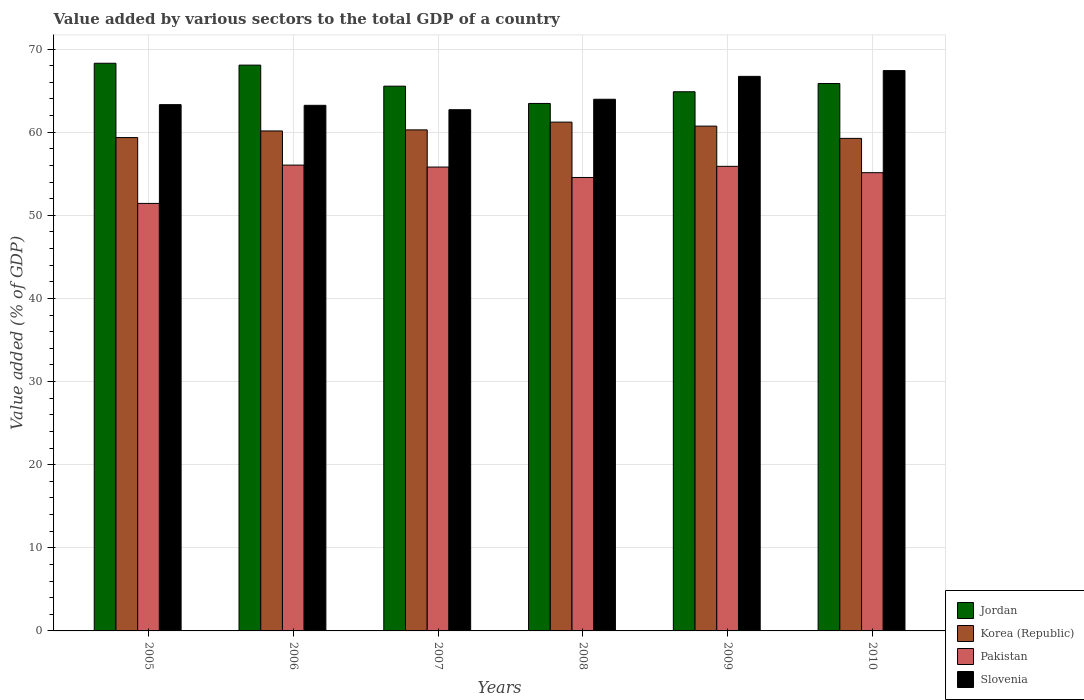How many bars are there on the 5th tick from the left?
Your answer should be very brief. 4. How many bars are there on the 6th tick from the right?
Offer a terse response. 4. What is the label of the 3rd group of bars from the left?
Your answer should be compact. 2007. What is the value added by various sectors to the total GDP in Pakistan in 2006?
Keep it short and to the point. 56.04. Across all years, what is the maximum value added by various sectors to the total GDP in Jordan?
Your response must be concise. 68.3. Across all years, what is the minimum value added by various sectors to the total GDP in Jordan?
Make the answer very short. 63.46. In which year was the value added by various sectors to the total GDP in Slovenia maximum?
Ensure brevity in your answer.  2010. What is the total value added by various sectors to the total GDP in Jordan in the graph?
Ensure brevity in your answer.  396.1. What is the difference between the value added by various sectors to the total GDP in Slovenia in 2005 and that in 2009?
Offer a very short reply. -3.4. What is the difference between the value added by various sectors to the total GDP in Korea (Republic) in 2010 and the value added by various sectors to the total GDP in Pakistan in 2005?
Provide a succinct answer. 7.83. What is the average value added by various sectors to the total GDP in Slovenia per year?
Provide a succinct answer. 64.56. In the year 2010, what is the difference between the value added by various sectors to the total GDP in Korea (Republic) and value added by various sectors to the total GDP in Slovenia?
Ensure brevity in your answer.  -8.15. In how many years, is the value added by various sectors to the total GDP in Slovenia greater than 38 %?
Your answer should be compact. 6. What is the ratio of the value added by various sectors to the total GDP in Pakistan in 2005 to that in 2010?
Your answer should be very brief. 0.93. Is the difference between the value added by various sectors to the total GDP in Korea (Republic) in 2007 and 2009 greater than the difference between the value added by various sectors to the total GDP in Slovenia in 2007 and 2009?
Give a very brief answer. Yes. What is the difference between the highest and the second highest value added by various sectors to the total GDP in Jordan?
Your response must be concise. 0.22. What is the difference between the highest and the lowest value added by various sectors to the total GDP in Pakistan?
Provide a short and direct response. 4.61. In how many years, is the value added by various sectors to the total GDP in Pakistan greater than the average value added by various sectors to the total GDP in Pakistan taken over all years?
Your response must be concise. 4. Is the sum of the value added by various sectors to the total GDP in Pakistan in 2005 and 2009 greater than the maximum value added by various sectors to the total GDP in Jordan across all years?
Your response must be concise. Yes. Is it the case that in every year, the sum of the value added by various sectors to the total GDP in Slovenia and value added by various sectors to the total GDP in Korea (Republic) is greater than the sum of value added by various sectors to the total GDP in Pakistan and value added by various sectors to the total GDP in Jordan?
Offer a very short reply. No. What does the 1st bar from the right in 2007 represents?
Offer a terse response. Slovenia. Is it the case that in every year, the sum of the value added by various sectors to the total GDP in Slovenia and value added by various sectors to the total GDP in Pakistan is greater than the value added by various sectors to the total GDP in Jordan?
Provide a short and direct response. Yes. Are the values on the major ticks of Y-axis written in scientific E-notation?
Offer a very short reply. No. Where does the legend appear in the graph?
Give a very brief answer. Bottom right. How are the legend labels stacked?
Your answer should be compact. Vertical. What is the title of the graph?
Your answer should be compact. Value added by various sectors to the total GDP of a country. Does "Paraguay" appear as one of the legend labels in the graph?
Provide a succinct answer. No. What is the label or title of the Y-axis?
Offer a very short reply. Value added (% of GDP). What is the Value added (% of GDP) in Jordan in 2005?
Your answer should be very brief. 68.3. What is the Value added (% of GDP) in Korea (Republic) in 2005?
Ensure brevity in your answer.  59.36. What is the Value added (% of GDP) in Pakistan in 2005?
Give a very brief answer. 51.43. What is the Value added (% of GDP) of Slovenia in 2005?
Make the answer very short. 63.32. What is the Value added (% of GDP) in Jordan in 2006?
Give a very brief answer. 68.07. What is the Value added (% of GDP) in Korea (Republic) in 2006?
Your answer should be very brief. 60.15. What is the Value added (% of GDP) of Pakistan in 2006?
Offer a very short reply. 56.04. What is the Value added (% of GDP) of Slovenia in 2006?
Offer a terse response. 63.24. What is the Value added (% of GDP) of Jordan in 2007?
Offer a very short reply. 65.54. What is the Value added (% of GDP) of Korea (Republic) in 2007?
Keep it short and to the point. 60.28. What is the Value added (% of GDP) of Pakistan in 2007?
Your answer should be very brief. 55.81. What is the Value added (% of GDP) of Slovenia in 2007?
Provide a short and direct response. 62.71. What is the Value added (% of GDP) of Jordan in 2008?
Offer a terse response. 63.46. What is the Value added (% of GDP) in Korea (Republic) in 2008?
Ensure brevity in your answer.  61.21. What is the Value added (% of GDP) of Pakistan in 2008?
Give a very brief answer. 54.56. What is the Value added (% of GDP) of Slovenia in 2008?
Your response must be concise. 63.96. What is the Value added (% of GDP) in Jordan in 2009?
Make the answer very short. 64.87. What is the Value added (% of GDP) in Korea (Republic) in 2009?
Provide a succinct answer. 60.73. What is the Value added (% of GDP) in Pakistan in 2009?
Make the answer very short. 55.89. What is the Value added (% of GDP) in Slovenia in 2009?
Ensure brevity in your answer.  66.72. What is the Value added (% of GDP) of Jordan in 2010?
Your response must be concise. 65.86. What is the Value added (% of GDP) in Korea (Republic) in 2010?
Offer a very short reply. 59.26. What is the Value added (% of GDP) of Pakistan in 2010?
Offer a very short reply. 55.13. What is the Value added (% of GDP) in Slovenia in 2010?
Give a very brief answer. 67.41. Across all years, what is the maximum Value added (% of GDP) in Jordan?
Your answer should be very brief. 68.3. Across all years, what is the maximum Value added (% of GDP) of Korea (Republic)?
Give a very brief answer. 61.21. Across all years, what is the maximum Value added (% of GDP) of Pakistan?
Ensure brevity in your answer.  56.04. Across all years, what is the maximum Value added (% of GDP) in Slovenia?
Make the answer very short. 67.41. Across all years, what is the minimum Value added (% of GDP) of Jordan?
Give a very brief answer. 63.46. Across all years, what is the minimum Value added (% of GDP) of Korea (Republic)?
Offer a terse response. 59.26. Across all years, what is the minimum Value added (% of GDP) in Pakistan?
Keep it short and to the point. 51.43. Across all years, what is the minimum Value added (% of GDP) in Slovenia?
Your answer should be compact. 62.71. What is the total Value added (% of GDP) in Jordan in the graph?
Your answer should be compact. 396.1. What is the total Value added (% of GDP) of Korea (Republic) in the graph?
Offer a very short reply. 361. What is the total Value added (% of GDP) of Pakistan in the graph?
Provide a short and direct response. 328.87. What is the total Value added (% of GDP) of Slovenia in the graph?
Offer a very short reply. 387.36. What is the difference between the Value added (% of GDP) in Jordan in 2005 and that in 2006?
Make the answer very short. 0.22. What is the difference between the Value added (% of GDP) in Korea (Republic) in 2005 and that in 2006?
Keep it short and to the point. -0.8. What is the difference between the Value added (% of GDP) of Pakistan in 2005 and that in 2006?
Offer a very short reply. -4.61. What is the difference between the Value added (% of GDP) in Slovenia in 2005 and that in 2006?
Your answer should be very brief. 0.08. What is the difference between the Value added (% of GDP) in Jordan in 2005 and that in 2007?
Your answer should be compact. 2.76. What is the difference between the Value added (% of GDP) in Korea (Republic) in 2005 and that in 2007?
Offer a terse response. -0.93. What is the difference between the Value added (% of GDP) in Pakistan in 2005 and that in 2007?
Ensure brevity in your answer.  -4.37. What is the difference between the Value added (% of GDP) in Slovenia in 2005 and that in 2007?
Make the answer very short. 0.61. What is the difference between the Value added (% of GDP) of Jordan in 2005 and that in 2008?
Ensure brevity in your answer.  4.83. What is the difference between the Value added (% of GDP) of Korea (Republic) in 2005 and that in 2008?
Your answer should be very brief. -1.86. What is the difference between the Value added (% of GDP) of Pakistan in 2005 and that in 2008?
Keep it short and to the point. -3.12. What is the difference between the Value added (% of GDP) of Slovenia in 2005 and that in 2008?
Offer a very short reply. -0.65. What is the difference between the Value added (% of GDP) in Jordan in 2005 and that in 2009?
Give a very brief answer. 3.43. What is the difference between the Value added (% of GDP) in Korea (Republic) in 2005 and that in 2009?
Ensure brevity in your answer.  -1.38. What is the difference between the Value added (% of GDP) of Pakistan in 2005 and that in 2009?
Your answer should be very brief. -4.46. What is the difference between the Value added (% of GDP) in Slovenia in 2005 and that in 2009?
Your answer should be very brief. -3.4. What is the difference between the Value added (% of GDP) in Jordan in 2005 and that in 2010?
Make the answer very short. 2.44. What is the difference between the Value added (% of GDP) of Korea (Republic) in 2005 and that in 2010?
Provide a succinct answer. 0.1. What is the difference between the Value added (% of GDP) of Pakistan in 2005 and that in 2010?
Your answer should be very brief. -3.7. What is the difference between the Value added (% of GDP) of Slovenia in 2005 and that in 2010?
Provide a succinct answer. -4.09. What is the difference between the Value added (% of GDP) of Jordan in 2006 and that in 2007?
Your response must be concise. 2.53. What is the difference between the Value added (% of GDP) in Korea (Republic) in 2006 and that in 2007?
Keep it short and to the point. -0.13. What is the difference between the Value added (% of GDP) in Pakistan in 2006 and that in 2007?
Offer a very short reply. 0.24. What is the difference between the Value added (% of GDP) of Slovenia in 2006 and that in 2007?
Your answer should be compact. 0.53. What is the difference between the Value added (% of GDP) in Jordan in 2006 and that in 2008?
Offer a very short reply. 4.61. What is the difference between the Value added (% of GDP) in Korea (Republic) in 2006 and that in 2008?
Give a very brief answer. -1.06. What is the difference between the Value added (% of GDP) of Pakistan in 2006 and that in 2008?
Offer a terse response. 1.49. What is the difference between the Value added (% of GDP) in Slovenia in 2006 and that in 2008?
Ensure brevity in your answer.  -0.73. What is the difference between the Value added (% of GDP) in Jordan in 2006 and that in 2009?
Your answer should be very brief. 3.21. What is the difference between the Value added (% of GDP) in Korea (Republic) in 2006 and that in 2009?
Ensure brevity in your answer.  -0.58. What is the difference between the Value added (% of GDP) in Pakistan in 2006 and that in 2009?
Offer a very short reply. 0.15. What is the difference between the Value added (% of GDP) in Slovenia in 2006 and that in 2009?
Make the answer very short. -3.48. What is the difference between the Value added (% of GDP) in Jordan in 2006 and that in 2010?
Your answer should be very brief. 2.21. What is the difference between the Value added (% of GDP) in Korea (Republic) in 2006 and that in 2010?
Your response must be concise. 0.89. What is the difference between the Value added (% of GDP) in Pakistan in 2006 and that in 2010?
Your answer should be compact. 0.91. What is the difference between the Value added (% of GDP) of Slovenia in 2006 and that in 2010?
Your answer should be compact. -4.18. What is the difference between the Value added (% of GDP) of Jordan in 2007 and that in 2008?
Make the answer very short. 2.08. What is the difference between the Value added (% of GDP) of Korea (Republic) in 2007 and that in 2008?
Offer a terse response. -0.93. What is the difference between the Value added (% of GDP) in Pakistan in 2007 and that in 2008?
Your response must be concise. 1.25. What is the difference between the Value added (% of GDP) of Slovenia in 2007 and that in 2008?
Offer a very short reply. -1.26. What is the difference between the Value added (% of GDP) in Jordan in 2007 and that in 2009?
Offer a very short reply. 0.67. What is the difference between the Value added (% of GDP) in Korea (Republic) in 2007 and that in 2009?
Provide a short and direct response. -0.45. What is the difference between the Value added (% of GDP) in Pakistan in 2007 and that in 2009?
Your answer should be very brief. -0.09. What is the difference between the Value added (% of GDP) in Slovenia in 2007 and that in 2009?
Offer a very short reply. -4.01. What is the difference between the Value added (% of GDP) of Jordan in 2007 and that in 2010?
Provide a short and direct response. -0.32. What is the difference between the Value added (% of GDP) of Korea (Republic) in 2007 and that in 2010?
Give a very brief answer. 1.02. What is the difference between the Value added (% of GDP) of Pakistan in 2007 and that in 2010?
Your response must be concise. 0.68. What is the difference between the Value added (% of GDP) in Slovenia in 2007 and that in 2010?
Ensure brevity in your answer.  -4.7. What is the difference between the Value added (% of GDP) in Jordan in 2008 and that in 2009?
Give a very brief answer. -1.41. What is the difference between the Value added (% of GDP) of Korea (Republic) in 2008 and that in 2009?
Give a very brief answer. 0.48. What is the difference between the Value added (% of GDP) in Pakistan in 2008 and that in 2009?
Offer a very short reply. -1.34. What is the difference between the Value added (% of GDP) in Slovenia in 2008 and that in 2009?
Keep it short and to the point. -2.75. What is the difference between the Value added (% of GDP) in Jordan in 2008 and that in 2010?
Provide a succinct answer. -2.4. What is the difference between the Value added (% of GDP) of Korea (Republic) in 2008 and that in 2010?
Your response must be concise. 1.96. What is the difference between the Value added (% of GDP) of Pakistan in 2008 and that in 2010?
Offer a terse response. -0.58. What is the difference between the Value added (% of GDP) in Slovenia in 2008 and that in 2010?
Keep it short and to the point. -3.45. What is the difference between the Value added (% of GDP) in Jordan in 2009 and that in 2010?
Your answer should be compact. -0.99. What is the difference between the Value added (% of GDP) of Korea (Republic) in 2009 and that in 2010?
Offer a terse response. 1.47. What is the difference between the Value added (% of GDP) of Pakistan in 2009 and that in 2010?
Provide a short and direct response. 0.76. What is the difference between the Value added (% of GDP) of Slovenia in 2009 and that in 2010?
Your response must be concise. -0.69. What is the difference between the Value added (% of GDP) of Jordan in 2005 and the Value added (% of GDP) of Korea (Republic) in 2006?
Give a very brief answer. 8.14. What is the difference between the Value added (% of GDP) in Jordan in 2005 and the Value added (% of GDP) in Pakistan in 2006?
Give a very brief answer. 12.25. What is the difference between the Value added (% of GDP) in Jordan in 2005 and the Value added (% of GDP) in Slovenia in 2006?
Your answer should be very brief. 5.06. What is the difference between the Value added (% of GDP) in Korea (Republic) in 2005 and the Value added (% of GDP) in Pakistan in 2006?
Offer a very short reply. 3.31. What is the difference between the Value added (% of GDP) in Korea (Republic) in 2005 and the Value added (% of GDP) in Slovenia in 2006?
Offer a very short reply. -3.88. What is the difference between the Value added (% of GDP) in Pakistan in 2005 and the Value added (% of GDP) in Slovenia in 2006?
Offer a terse response. -11.8. What is the difference between the Value added (% of GDP) of Jordan in 2005 and the Value added (% of GDP) of Korea (Republic) in 2007?
Keep it short and to the point. 8.02. What is the difference between the Value added (% of GDP) of Jordan in 2005 and the Value added (% of GDP) of Pakistan in 2007?
Your answer should be compact. 12.49. What is the difference between the Value added (% of GDP) of Jordan in 2005 and the Value added (% of GDP) of Slovenia in 2007?
Make the answer very short. 5.59. What is the difference between the Value added (% of GDP) in Korea (Republic) in 2005 and the Value added (% of GDP) in Pakistan in 2007?
Keep it short and to the point. 3.55. What is the difference between the Value added (% of GDP) in Korea (Republic) in 2005 and the Value added (% of GDP) in Slovenia in 2007?
Your answer should be very brief. -3.35. What is the difference between the Value added (% of GDP) of Pakistan in 2005 and the Value added (% of GDP) of Slovenia in 2007?
Your answer should be compact. -11.27. What is the difference between the Value added (% of GDP) in Jordan in 2005 and the Value added (% of GDP) in Korea (Republic) in 2008?
Your answer should be compact. 7.08. What is the difference between the Value added (% of GDP) in Jordan in 2005 and the Value added (% of GDP) in Pakistan in 2008?
Provide a succinct answer. 13.74. What is the difference between the Value added (% of GDP) in Jordan in 2005 and the Value added (% of GDP) in Slovenia in 2008?
Ensure brevity in your answer.  4.33. What is the difference between the Value added (% of GDP) in Korea (Republic) in 2005 and the Value added (% of GDP) in Pakistan in 2008?
Ensure brevity in your answer.  4.8. What is the difference between the Value added (% of GDP) in Korea (Republic) in 2005 and the Value added (% of GDP) in Slovenia in 2008?
Your answer should be compact. -4.61. What is the difference between the Value added (% of GDP) in Pakistan in 2005 and the Value added (% of GDP) in Slovenia in 2008?
Your answer should be compact. -12.53. What is the difference between the Value added (% of GDP) of Jordan in 2005 and the Value added (% of GDP) of Korea (Republic) in 2009?
Provide a short and direct response. 7.56. What is the difference between the Value added (% of GDP) in Jordan in 2005 and the Value added (% of GDP) in Pakistan in 2009?
Ensure brevity in your answer.  12.4. What is the difference between the Value added (% of GDP) of Jordan in 2005 and the Value added (% of GDP) of Slovenia in 2009?
Keep it short and to the point. 1.58. What is the difference between the Value added (% of GDP) of Korea (Republic) in 2005 and the Value added (% of GDP) of Pakistan in 2009?
Your response must be concise. 3.46. What is the difference between the Value added (% of GDP) of Korea (Republic) in 2005 and the Value added (% of GDP) of Slovenia in 2009?
Provide a succinct answer. -7.36. What is the difference between the Value added (% of GDP) of Pakistan in 2005 and the Value added (% of GDP) of Slovenia in 2009?
Offer a terse response. -15.29. What is the difference between the Value added (% of GDP) of Jordan in 2005 and the Value added (% of GDP) of Korea (Republic) in 2010?
Keep it short and to the point. 9.04. What is the difference between the Value added (% of GDP) in Jordan in 2005 and the Value added (% of GDP) in Pakistan in 2010?
Offer a terse response. 13.16. What is the difference between the Value added (% of GDP) of Jordan in 2005 and the Value added (% of GDP) of Slovenia in 2010?
Offer a terse response. 0.88. What is the difference between the Value added (% of GDP) in Korea (Republic) in 2005 and the Value added (% of GDP) in Pakistan in 2010?
Keep it short and to the point. 4.22. What is the difference between the Value added (% of GDP) in Korea (Republic) in 2005 and the Value added (% of GDP) in Slovenia in 2010?
Offer a very short reply. -8.06. What is the difference between the Value added (% of GDP) of Pakistan in 2005 and the Value added (% of GDP) of Slovenia in 2010?
Offer a very short reply. -15.98. What is the difference between the Value added (% of GDP) in Jordan in 2006 and the Value added (% of GDP) in Korea (Republic) in 2007?
Provide a short and direct response. 7.79. What is the difference between the Value added (% of GDP) of Jordan in 2006 and the Value added (% of GDP) of Pakistan in 2007?
Give a very brief answer. 12.27. What is the difference between the Value added (% of GDP) of Jordan in 2006 and the Value added (% of GDP) of Slovenia in 2007?
Provide a short and direct response. 5.37. What is the difference between the Value added (% of GDP) of Korea (Republic) in 2006 and the Value added (% of GDP) of Pakistan in 2007?
Provide a succinct answer. 4.35. What is the difference between the Value added (% of GDP) in Korea (Republic) in 2006 and the Value added (% of GDP) in Slovenia in 2007?
Offer a very short reply. -2.56. What is the difference between the Value added (% of GDP) in Pakistan in 2006 and the Value added (% of GDP) in Slovenia in 2007?
Make the answer very short. -6.66. What is the difference between the Value added (% of GDP) in Jordan in 2006 and the Value added (% of GDP) in Korea (Republic) in 2008?
Your response must be concise. 6.86. What is the difference between the Value added (% of GDP) of Jordan in 2006 and the Value added (% of GDP) of Pakistan in 2008?
Make the answer very short. 13.52. What is the difference between the Value added (% of GDP) in Jordan in 2006 and the Value added (% of GDP) in Slovenia in 2008?
Your response must be concise. 4.11. What is the difference between the Value added (% of GDP) in Korea (Republic) in 2006 and the Value added (% of GDP) in Pakistan in 2008?
Give a very brief answer. 5.6. What is the difference between the Value added (% of GDP) of Korea (Republic) in 2006 and the Value added (% of GDP) of Slovenia in 2008?
Keep it short and to the point. -3.81. What is the difference between the Value added (% of GDP) in Pakistan in 2006 and the Value added (% of GDP) in Slovenia in 2008?
Give a very brief answer. -7.92. What is the difference between the Value added (% of GDP) of Jordan in 2006 and the Value added (% of GDP) of Korea (Republic) in 2009?
Give a very brief answer. 7.34. What is the difference between the Value added (% of GDP) in Jordan in 2006 and the Value added (% of GDP) in Pakistan in 2009?
Ensure brevity in your answer.  12.18. What is the difference between the Value added (% of GDP) of Jordan in 2006 and the Value added (% of GDP) of Slovenia in 2009?
Your answer should be compact. 1.35. What is the difference between the Value added (% of GDP) in Korea (Republic) in 2006 and the Value added (% of GDP) in Pakistan in 2009?
Offer a terse response. 4.26. What is the difference between the Value added (% of GDP) of Korea (Republic) in 2006 and the Value added (% of GDP) of Slovenia in 2009?
Provide a short and direct response. -6.57. What is the difference between the Value added (% of GDP) in Pakistan in 2006 and the Value added (% of GDP) in Slovenia in 2009?
Make the answer very short. -10.67. What is the difference between the Value added (% of GDP) in Jordan in 2006 and the Value added (% of GDP) in Korea (Republic) in 2010?
Offer a terse response. 8.81. What is the difference between the Value added (% of GDP) in Jordan in 2006 and the Value added (% of GDP) in Pakistan in 2010?
Offer a terse response. 12.94. What is the difference between the Value added (% of GDP) of Jordan in 2006 and the Value added (% of GDP) of Slovenia in 2010?
Offer a terse response. 0.66. What is the difference between the Value added (% of GDP) in Korea (Republic) in 2006 and the Value added (% of GDP) in Pakistan in 2010?
Provide a short and direct response. 5.02. What is the difference between the Value added (% of GDP) of Korea (Republic) in 2006 and the Value added (% of GDP) of Slovenia in 2010?
Your answer should be compact. -7.26. What is the difference between the Value added (% of GDP) in Pakistan in 2006 and the Value added (% of GDP) in Slovenia in 2010?
Make the answer very short. -11.37. What is the difference between the Value added (% of GDP) in Jordan in 2007 and the Value added (% of GDP) in Korea (Republic) in 2008?
Keep it short and to the point. 4.33. What is the difference between the Value added (% of GDP) in Jordan in 2007 and the Value added (% of GDP) in Pakistan in 2008?
Your response must be concise. 10.99. What is the difference between the Value added (% of GDP) in Jordan in 2007 and the Value added (% of GDP) in Slovenia in 2008?
Your answer should be very brief. 1.58. What is the difference between the Value added (% of GDP) of Korea (Republic) in 2007 and the Value added (% of GDP) of Pakistan in 2008?
Keep it short and to the point. 5.73. What is the difference between the Value added (% of GDP) in Korea (Republic) in 2007 and the Value added (% of GDP) in Slovenia in 2008?
Your answer should be compact. -3.68. What is the difference between the Value added (% of GDP) of Pakistan in 2007 and the Value added (% of GDP) of Slovenia in 2008?
Give a very brief answer. -8.16. What is the difference between the Value added (% of GDP) in Jordan in 2007 and the Value added (% of GDP) in Korea (Republic) in 2009?
Keep it short and to the point. 4.81. What is the difference between the Value added (% of GDP) of Jordan in 2007 and the Value added (% of GDP) of Pakistan in 2009?
Your response must be concise. 9.65. What is the difference between the Value added (% of GDP) of Jordan in 2007 and the Value added (% of GDP) of Slovenia in 2009?
Offer a very short reply. -1.18. What is the difference between the Value added (% of GDP) of Korea (Republic) in 2007 and the Value added (% of GDP) of Pakistan in 2009?
Offer a very short reply. 4.39. What is the difference between the Value added (% of GDP) of Korea (Republic) in 2007 and the Value added (% of GDP) of Slovenia in 2009?
Offer a very short reply. -6.44. What is the difference between the Value added (% of GDP) of Pakistan in 2007 and the Value added (% of GDP) of Slovenia in 2009?
Keep it short and to the point. -10.91. What is the difference between the Value added (% of GDP) in Jordan in 2007 and the Value added (% of GDP) in Korea (Republic) in 2010?
Provide a succinct answer. 6.28. What is the difference between the Value added (% of GDP) in Jordan in 2007 and the Value added (% of GDP) in Pakistan in 2010?
Your response must be concise. 10.41. What is the difference between the Value added (% of GDP) of Jordan in 2007 and the Value added (% of GDP) of Slovenia in 2010?
Make the answer very short. -1.87. What is the difference between the Value added (% of GDP) in Korea (Republic) in 2007 and the Value added (% of GDP) in Pakistan in 2010?
Provide a succinct answer. 5.15. What is the difference between the Value added (% of GDP) in Korea (Republic) in 2007 and the Value added (% of GDP) in Slovenia in 2010?
Offer a very short reply. -7.13. What is the difference between the Value added (% of GDP) of Pakistan in 2007 and the Value added (% of GDP) of Slovenia in 2010?
Ensure brevity in your answer.  -11.6. What is the difference between the Value added (% of GDP) of Jordan in 2008 and the Value added (% of GDP) of Korea (Republic) in 2009?
Give a very brief answer. 2.73. What is the difference between the Value added (% of GDP) in Jordan in 2008 and the Value added (% of GDP) in Pakistan in 2009?
Offer a very short reply. 7.57. What is the difference between the Value added (% of GDP) in Jordan in 2008 and the Value added (% of GDP) in Slovenia in 2009?
Offer a very short reply. -3.26. What is the difference between the Value added (% of GDP) of Korea (Republic) in 2008 and the Value added (% of GDP) of Pakistan in 2009?
Your answer should be very brief. 5.32. What is the difference between the Value added (% of GDP) of Korea (Republic) in 2008 and the Value added (% of GDP) of Slovenia in 2009?
Keep it short and to the point. -5.5. What is the difference between the Value added (% of GDP) of Pakistan in 2008 and the Value added (% of GDP) of Slovenia in 2009?
Keep it short and to the point. -12.16. What is the difference between the Value added (% of GDP) in Jordan in 2008 and the Value added (% of GDP) in Korea (Republic) in 2010?
Give a very brief answer. 4.2. What is the difference between the Value added (% of GDP) in Jordan in 2008 and the Value added (% of GDP) in Pakistan in 2010?
Provide a succinct answer. 8.33. What is the difference between the Value added (% of GDP) in Jordan in 2008 and the Value added (% of GDP) in Slovenia in 2010?
Keep it short and to the point. -3.95. What is the difference between the Value added (% of GDP) in Korea (Republic) in 2008 and the Value added (% of GDP) in Pakistan in 2010?
Provide a short and direct response. 6.08. What is the difference between the Value added (% of GDP) in Korea (Republic) in 2008 and the Value added (% of GDP) in Slovenia in 2010?
Offer a very short reply. -6.2. What is the difference between the Value added (% of GDP) of Pakistan in 2008 and the Value added (% of GDP) of Slovenia in 2010?
Offer a very short reply. -12.86. What is the difference between the Value added (% of GDP) in Jordan in 2009 and the Value added (% of GDP) in Korea (Republic) in 2010?
Ensure brevity in your answer.  5.61. What is the difference between the Value added (% of GDP) in Jordan in 2009 and the Value added (% of GDP) in Pakistan in 2010?
Give a very brief answer. 9.74. What is the difference between the Value added (% of GDP) of Jordan in 2009 and the Value added (% of GDP) of Slovenia in 2010?
Provide a succinct answer. -2.54. What is the difference between the Value added (% of GDP) of Korea (Republic) in 2009 and the Value added (% of GDP) of Pakistan in 2010?
Your response must be concise. 5.6. What is the difference between the Value added (% of GDP) in Korea (Republic) in 2009 and the Value added (% of GDP) in Slovenia in 2010?
Your response must be concise. -6.68. What is the difference between the Value added (% of GDP) of Pakistan in 2009 and the Value added (% of GDP) of Slovenia in 2010?
Your answer should be compact. -11.52. What is the average Value added (% of GDP) in Jordan per year?
Keep it short and to the point. 66.02. What is the average Value added (% of GDP) of Korea (Republic) per year?
Your response must be concise. 60.17. What is the average Value added (% of GDP) in Pakistan per year?
Keep it short and to the point. 54.81. What is the average Value added (% of GDP) in Slovenia per year?
Keep it short and to the point. 64.56. In the year 2005, what is the difference between the Value added (% of GDP) of Jordan and Value added (% of GDP) of Korea (Republic)?
Keep it short and to the point. 8.94. In the year 2005, what is the difference between the Value added (% of GDP) of Jordan and Value added (% of GDP) of Pakistan?
Your response must be concise. 16.86. In the year 2005, what is the difference between the Value added (% of GDP) of Jordan and Value added (% of GDP) of Slovenia?
Ensure brevity in your answer.  4.98. In the year 2005, what is the difference between the Value added (% of GDP) in Korea (Republic) and Value added (% of GDP) in Pakistan?
Ensure brevity in your answer.  7.92. In the year 2005, what is the difference between the Value added (% of GDP) in Korea (Republic) and Value added (% of GDP) in Slovenia?
Offer a very short reply. -3.96. In the year 2005, what is the difference between the Value added (% of GDP) in Pakistan and Value added (% of GDP) in Slovenia?
Your answer should be compact. -11.88. In the year 2006, what is the difference between the Value added (% of GDP) of Jordan and Value added (% of GDP) of Korea (Republic)?
Provide a short and direct response. 7.92. In the year 2006, what is the difference between the Value added (% of GDP) of Jordan and Value added (% of GDP) of Pakistan?
Offer a very short reply. 12.03. In the year 2006, what is the difference between the Value added (% of GDP) in Jordan and Value added (% of GDP) in Slovenia?
Offer a terse response. 4.84. In the year 2006, what is the difference between the Value added (% of GDP) of Korea (Republic) and Value added (% of GDP) of Pakistan?
Keep it short and to the point. 4.11. In the year 2006, what is the difference between the Value added (% of GDP) of Korea (Republic) and Value added (% of GDP) of Slovenia?
Give a very brief answer. -3.08. In the year 2006, what is the difference between the Value added (% of GDP) in Pakistan and Value added (% of GDP) in Slovenia?
Offer a terse response. -7.19. In the year 2007, what is the difference between the Value added (% of GDP) of Jordan and Value added (% of GDP) of Korea (Republic)?
Provide a short and direct response. 5.26. In the year 2007, what is the difference between the Value added (% of GDP) of Jordan and Value added (% of GDP) of Pakistan?
Provide a short and direct response. 9.73. In the year 2007, what is the difference between the Value added (% of GDP) of Jordan and Value added (% of GDP) of Slovenia?
Ensure brevity in your answer.  2.83. In the year 2007, what is the difference between the Value added (% of GDP) of Korea (Republic) and Value added (% of GDP) of Pakistan?
Offer a terse response. 4.47. In the year 2007, what is the difference between the Value added (% of GDP) of Korea (Republic) and Value added (% of GDP) of Slovenia?
Ensure brevity in your answer.  -2.43. In the year 2007, what is the difference between the Value added (% of GDP) in Pakistan and Value added (% of GDP) in Slovenia?
Your answer should be compact. -6.9. In the year 2008, what is the difference between the Value added (% of GDP) in Jordan and Value added (% of GDP) in Korea (Republic)?
Provide a short and direct response. 2.25. In the year 2008, what is the difference between the Value added (% of GDP) of Jordan and Value added (% of GDP) of Pakistan?
Offer a terse response. 8.91. In the year 2008, what is the difference between the Value added (% of GDP) in Jordan and Value added (% of GDP) in Slovenia?
Your answer should be compact. -0.5. In the year 2008, what is the difference between the Value added (% of GDP) of Korea (Republic) and Value added (% of GDP) of Pakistan?
Ensure brevity in your answer.  6.66. In the year 2008, what is the difference between the Value added (% of GDP) of Korea (Republic) and Value added (% of GDP) of Slovenia?
Provide a succinct answer. -2.75. In the year 2008, what is the difference between the Value added (% of GDP) in Pakistan and Value added (% of GDP) in Slovenia?
Keep it short and to the point. -9.41. In the year 2009, what is the difference between the Value added (% of GDP) of Jordan and Value added (% of GDP) of Korea (Republic)?
Provide a short and direct response. 4.13. In the year 2009, what is the difference between the Value added (% of GDP) in Jordan and Value added (% of GDP) in Pakistan?
Your response must be concise. 8.97. In the year 2009, what is the difference between the Value added (% of GDP) in Jordan and Value added (% of GDP) in Slovenia?
Keep it short and to the point. -1.85. In the year 2009, what is the difference between the Value added (% of GDP) in Korea (Republic) and Value added (% of GDP) in Pakistan?
Keep it short and to the point. 4.84. In the year 2009, what is the difference between the Value added (% of GDP) of Korea (Republic) and Value added (% of GDP) of Slovenia?
Your answer should be compact. -5.99. In the year 2009, what is the difference between the Value added (% of GDP) in Pakistan and Value added (% of GDP) in Slovenia?
Give a very brief answer. -10.82. In the year 2010, what is the difference between the Value added (% of GDP) in Jordan and Value added (% of GDP) in Korea (Republic)?
Offer a terse response. 6.6. In the year 2010, what is the difference between the Value added (% of GDP) of Jordan and Value added (% of GDP) of Pakistan?
Ensure brevity in your answer.  10.73. In the year 2010, what is the difference between the Value added (% of GDP) in Jordan and Value added (% of GDP) in Slovenia?
Your answer should be compact. -1.55. In the year 2010, what is the difference between the Value added (% of GDP) of Korea (Republic) and Value added (% of GDP) of Pakistan?
Offer a terse response. 4.13. In the year 2010, what is the difference between the Value added (% of GDP) of Korea (Republic) and Value added (% of GDP) of Slovenia?
Your answer should be compact. -8.15. In the year 2010, what is the difference between the Value added (% of GDP) in Pakistan and Value added (% of GDP) in Slovenia?
Offer a terse response. -12.28. What is the ratio of the Value added (% of GDP) in Korea (Republic) in 2005 to that in 2006?
Offer a terse response. 0.99. What is the ratio of the Value added (% of GDP) in Pakistan in 2005 to that in 2006?
Ensure brevity in your answer.  0.92. What is the ratio of the Value added (% of GDP) in Jordan in 2005 to that in 2007?
Your answer should be compact. 1.04. What is the ratio of the Value added (% of GDP) in Korea (Republic) in 2005 to that in 2007?
Provide a succinct answer. 0.98. What is the ratio of the Value added (% of GDP) in Pakistan in 2005 to that in 2007?
Your response must be concise. 0.92. What is the ratio of the Value added (% of GDP) in Slovenia in 2005 to that in 2007?
Make the answer very short. 1.01. What is the ratio of the Value added (% of GDP) in Jordan in 2005 to that in 2008?
Your response must be concise. 1.08. What is the ratio of the Value added (% of GDP) in Korea (Republic) in 2005 to that in 2008?
Ensure brevity in your answer.  0.97. What is the ratio of the Value added (% of GDP) of Pakistan in 2005 to that in 2008?
Your response must be concise. 0.94. What is the ratio of the Value added (% of GDP) in Slovenia in 2005 to that in 2008?
Give a very brief answer. 0.99. What is the ratio of the Value added (% of GDP) in Jordan in 2005 to that in 2009?
Keep it short and to the point. 1.05. What is the ratio of the Value added (% of GDP) of Korea (Republic) in 2005 to that in 2009?
Provide a short and direct response. 0.98. What is the ratio of the Value added (% of GDP) in Pakistan in 2005 to that in 2009?
Keep it short and to the point. 0.92. What is the ratio of the Value added (% of GDP) in Slovenia in 2005 to that in 2009?
Give a very brief answer. 0.95. What is the ratio of the Value added (% of GDP) of Korea (Republic) in 2005 to that in 2010?
Ensure brevity in your answer.  1. What is the ratio of the Value added (% of GDP) of Pakistan in 2005 to that in 2010?
Your response must be concise. 0.93. What is the ratio of the Value added (% of GDP) of Slovenia in 2005 to that in 2010?
Your response must be concise. 0.94. What is the ratio of the Value added (% of GDP) in Jordan in 2006 to that in 2007?
Your answer should be very brief. 1.04. What is the ratio of the Value added (% of GDP) of Slovenia in 2006 to that in 2007?
Offer a terse response. 1.01. What is the ratio of the Value added (% of GDP) of Jordan in 2006 to that in 2008?
Offer a very short reply. 1.07. What is the ratio of the Value added (% of GDP) of Korea (Republic) in 2006 to that in 2008?
Make the answer very short. 0.98. What is the ratio of the Value added (% of GDP) in Pakistan in 2006 to that in 2008?
Your answer should be compact. 1.03. What is the ratio of the Value added (% of GDP) of Slovenia in 2006 to that in 2008?
Your response must be concise. 0.99. What is the ratio of the Value added (% of GDP) in Jordan in 2006 to that in 2009?
Your answer should be very brief. 1.05. What is the ratio of the Value added (% of GDP) of Korea (Republic) in 2006 to that in 2009?
Your answer should be very brief. 0.99. What is the ratio of the Value added (% of GDP) in Slovenia in 2006 to that in 2009?
Your answer should be very brief. 0.95. What is the ratio of the Value added (% of GDP) of Jordan in 2006 to that in 2010?
Keep it short and to the point. 1.03. What is the ratio of the Value added (% of GDP) in Korea (Republic) in 2006 to that in 2010?
Provide a succinct answer. 1.02. What is the ratio of the Value added (% of GDP) of Pakistan in 2006 to that in 2010?
Provide a short and direct response. 1.02. What is the ratio of the Value added (% of GDP) in Slovenia in 2006 to that in 2010?
Your answer should be compact. 0.94. What is the ratio of the Value added (% of GDP) of Jordan in 2007 to that in 2008?
Offer a terse response. 1.03. What is the ratio of the Value added (% of GDP) of Korea (Republic) in 2007 to that in 2008?
Provide a succinct answer. 0.98. What is the ratio of the Value added (% of GDP) in Pakistan in 2007 to that in 2008?
Provide a short and direct response. 1.02. What is the ratio of the Value added (% of GDP) of Slovenia in 2007 to that in 2008?
Your answer should be very brief. 0.98. What is the ratio of the Value added (% of GDP) of Jordan in 2007 to that in 2009?
Provide a short and direct response. 1.01. What is the ratio of the Value added (% of GDP) in Korea (Republic) in 2007 to that in 2009?
Ensure brevity in your answer.  0.99. What is the ratio of the Value added (% of GDP) of Pakistan in 2007 to that in 2009?
Your response must be concise. 1. What is the ratio of the Value added (% of GDP) of Slovenia in 2007 to that in 2009?
Your answer should be compact. 0.94. What is the ratio of the Value added (% of GDP) of Jordan in 2007 to that in 2010?
Your response must be concise. 1. What is the ratio of the Value added (% of GDP) of Korea (Republic) in 2007 to that in 2010?
Make the answer very short. 1.02. What is the ratio of the Value added (% of GDP) of Pakistan in 2007 to that in 2010?
Offer a very short reply. 1.01. What is the ratio of the Value added (% of GDP) of Slovenia in 2007 to that in 2010?
Provide a succinct answer. 0.93. What is the ratio of the Value added (% of GDP) of Jordan in 2008 to that in 2009?
Provide a short and direct response. 0.98. What is the ratio of the Value added (% of GDP) of Korea (Republic) in 2008 to that in 2009?
Your answer should be compact. 1.01. What is the ratio of the Value added (% of GDP) of Pakistan in 2008 to that in 2009?
Provide a short and direct response. 0.98. What is the ratio of the Value added (% of GDP) of Slovenia in 2008 to that in 2009?
Ensure brevity in your answer.  0.96. What is the ratio of the Value added (% of GDP) of Jordan in 2008 to that in 2010?
Your response must be concise. 0.96. What is the ratio of the Value added (% of GDP) of Korea (Republic) in 2008 to that in 2010?
Give a very brief answer. 1.03. What is the ratio of the Value added (% of GDP) in Slovenia in 2008 to that in 2010?
Provide a succinct answer. 0.95. What is the ratio of the Value added (% of GDP) of Jordan in 2009 to that in 2010?
Offer a terse response. 0.98. What is the ratio of the Value added (% of GDP) in Korea (Republic) in 2009 to that in 2010?
Ensure brevity in your answer.  1.02. What is the ratio of the Value added (% of GDP) in Pakistan in 2009 to that in 2010?
Give a very brief answer. 1.01. What is the ratio of the Value added (% of GDP) of Slovenia in 2009 to that in 2010?
Ensure brevity in your answer.  0.99. What is the difference between the highest and the second highest Value added (% of GDP) of Jordan?
Provide a succinct answer. 0.22. What is the difference between the highest and the second highest Value added (% of GDP) in Korea (Republic)?
Offer a terse response. 0.48. What is the difference between the highest and the second highest Value added (% of GDP) in Pakistan?
Ensure brevity in your answer.  0.15. What is the difference between the highest and the second highest Value added (% of GDP) of Slovenia?
Ensure brevity in your answer.  0.69. What is the difference between the highest and the lowest Value added (% of GDP) of Jordan?
Your answer should be very brief. 4.83. What is the difference between the highest and the lowest Value added (% of GDP) in Korea (Republic)?
Make the answer very short. 1.96. What is the difference between the highest and the lowest Value added (% of GDP) in Pakistan?
Offer a terse response. 4.61. What is the difference between the highest and the lowest Value added (% of GDP) in Slovenia?
Make the answer very short. 4.7. 